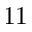Convert formula to latex. <formula><loc_0><loc_0><loc_500><loc_500>1 1</formula> 